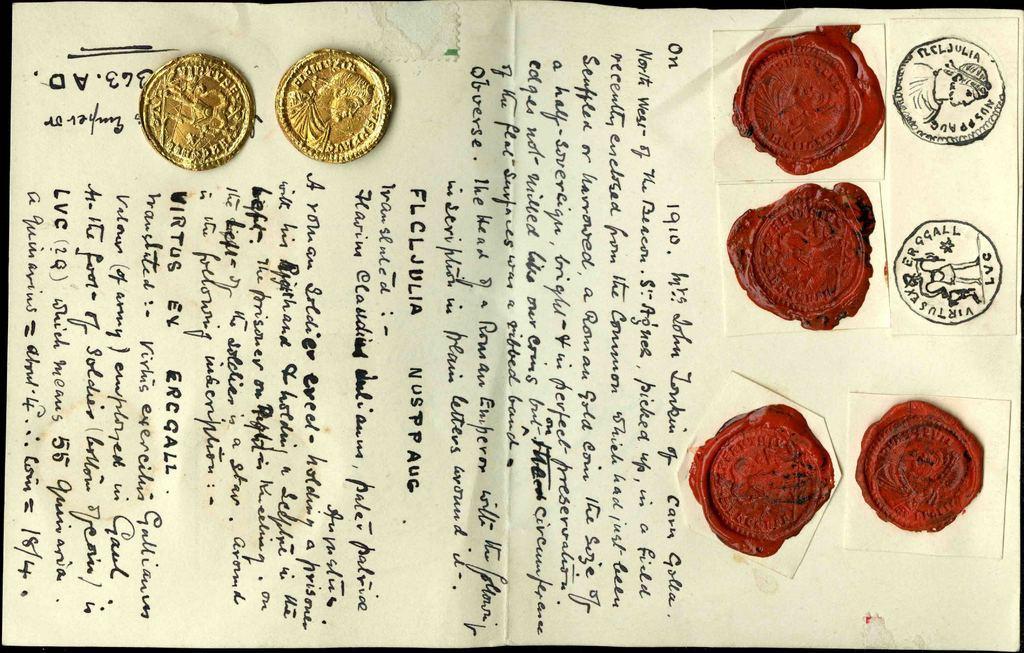In one or two sentences, can you explain what this image depicts? In this image there is a paper. There is text on the paper. In the top left there are coins on the paper. To the right there are wax stamps on the paper. 